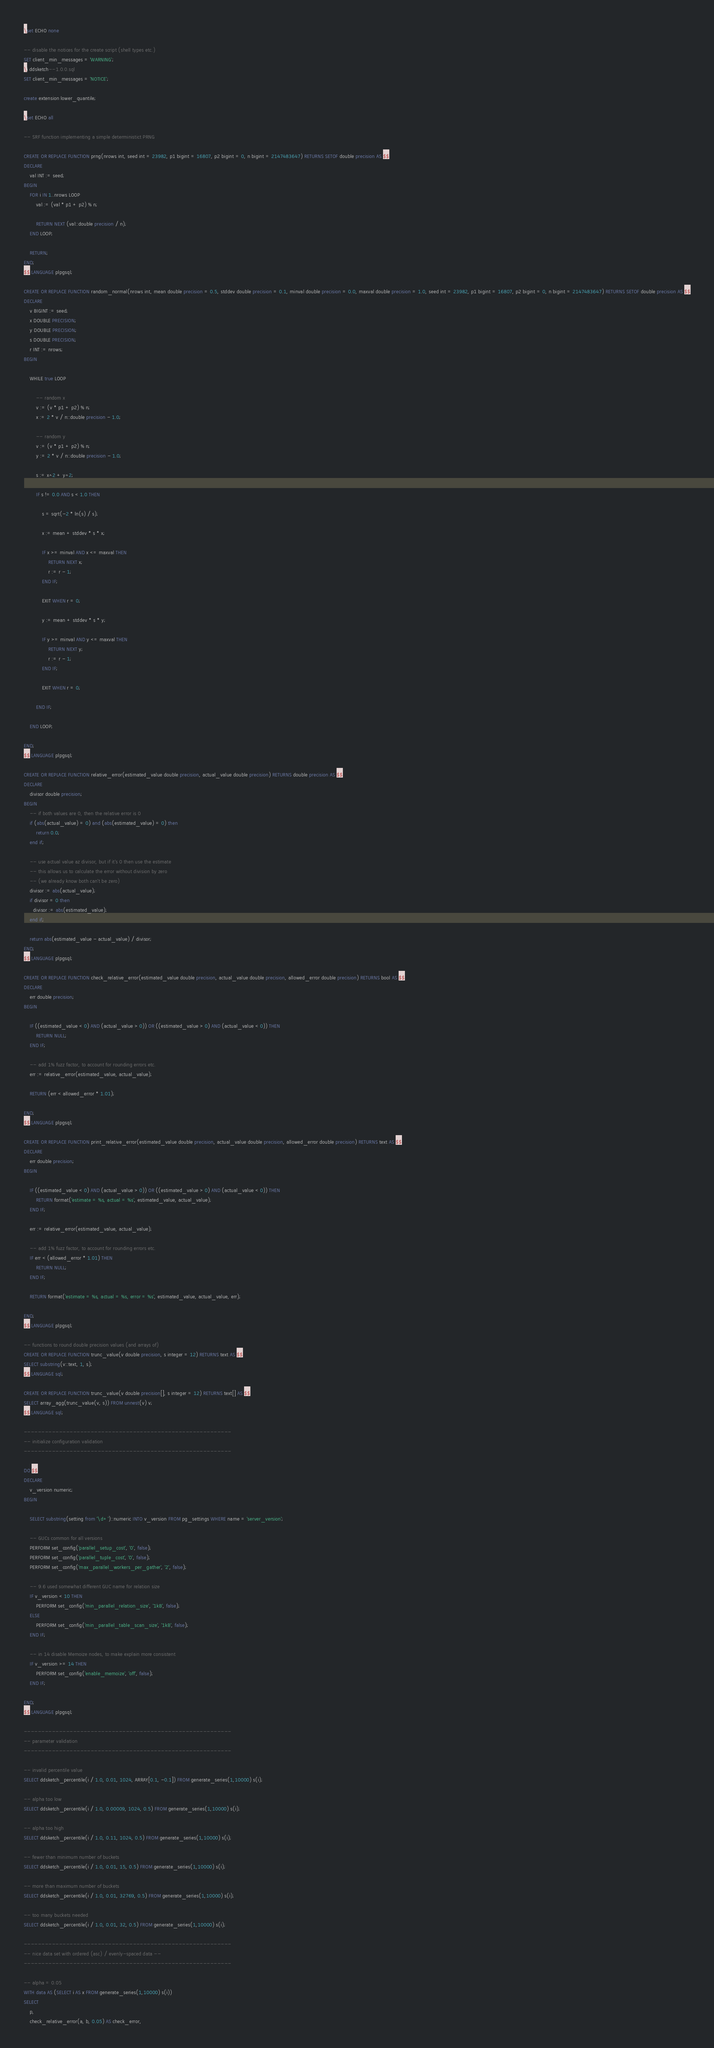<code> <loc_0><loc_0><loc_500><loc_500><_SQL_>\set ECHO none

-- disable the notices for the create script (shell types etc.)
SET client_min_messages = 'WARNING';
\i ddsketch--1.0.0.sql
SET client_min_messages = 'NOTICE';

create extension lower_quantile;

\set ECHO all

-- SRF function implementing a simple deterministict PRNG

CREATE OR REPLACE FUNCTION prng(nrows int, seed int = 23982, p1 bigint = 16807, p2 bigint = 0, n bigint = 2147483647) RETURNS SETOF double precision AS $$
DECLARE
    val INT := seed;
BEGIN
    FOR i IN 1..nrows LOOP
        val := (val * p1 + p2) % n;

        RETURN NEXT (val::double precision / n);
    END LOOP;

    RETURN;
END;
$$ LANGUAGE plpgsql;

CREATE OR REPLACE FUNCTION random_normal(nrows int, mean double precision = 0.5, stddev double precision = 0.1, minval double precision = 0.0, maxval double precision = 1.0, seed int = 23982, p1 bigint = 16807, p2 bigint = 0, n bigint = 2147483647) RETURNS SETOF double precision AS $$
DECLARE
    v BIGINT := seed;
    x DOUBLE PRECISION;
    y DOUBLE PRECISION;
    s DOUBLE PRECISION;
    r INT := nrows;
BEGIN

    WHILE true LOOP

        -- random x
        v := (v * p1 + p2) % n;
        x := 2 * v / n::double precision - 1.0;

        -- random y
        v := (v * p1 + p2) % n;
        y := 2 * v / n::double precision - 1.0;

        s := x^2 + y^2;

        IF s != 0.0 AND s < 1.0 THEN

            s = sqrt(-2 * ln(s) / s);

            x := mean + stddev * s * x;

            IF x >= minval AND x <= maxval THEN
                RETURN NEXT x;
                r := r - 1;
            END IF;

            EXIT WHEN r = 0;

            y := mean + stddev * s * y;

            IF y >= minval AND y <= maxval THEN
                RETURN NEXT y;
                r := r - 1;
            END IF;

            EXIT WHEN r = 0;

        END IF;

    END LOOP;

END;
$$ LANGUAGE plpgsql;

CREATE OR REPLACE FUNCTION relative_error(estimated_value double precision, actual_value double precision) RETURNS double precision AS $$
DECLARE
    divisor double precision;
BEGIN
    -- if both values are 0, then the relative error is 0
    if (abs(actual_value) = 0) and (abs(estimated_value) = 0) then
        return 0.0;
    end if;

    -- use actual value az divisor, but if it's 0 then use the estimate
    -- this allows us to calculate the error without division by zero
    -- (we already know both can't be zero)
    divisor := abs(actual_value);
    if divisor = 0 then
      divisor := abs(estimated_value);
    end if;

    return abs(estimated_value - actual_value) / divisor;
END;
$$ LANGUAGE plpgsql;

CREATE OR REPLACE FUNCTION check_relative_error(estimated_value double precision, actual_value double precision, allowed_error double precision) RETURNS bool AS $$
DECLARE
    err double precision;
BEGIN

    IF ((estimated_value < 0) AND (actual_value > 0)) OR ((estimated_value > 0) AND (actual_value < 0)) THEN
        RETURN NULL;
    END IF;

    -- add 1% fuzz factor, to account for rounding errors etc.
    err := relative_error(estimated_value, actual_value);

    RETURN (err < allowed_error * 1.01);

END;
$$ LANGUAGE plpgsql;

CREATE OR REPLACE FUNCTION print_relative_error(estimated_value double precision, actual_value double precision, allowed_error double precision) RETURNS text AS $$
DECLARE
    err double precision;
BEGIN

    IF ((estimated_value < 0) AND (actual_value > 0)) OR ((estimated_value > 0) AND (actual_value < 0)) THEN
        RETURN format('estimate = %s, actual = %s', estimated_value, actual_value);
    END IF;

    err := relative_error(estimated_value, actual_value);

    -- add 1% fuzz factor, to account for rounding errors etc.
    IF err < (allowed_error * 1.01) THEN
        RETURN NULL;
    END IF;

    RETURN format('estimate = %s, actual = %s, error = %s', estimated_value, actual_value, err);

END;
$$ LANGUAGE plpgsql;

-- functions to round double precision values (and arrays of)
CREATE OR REPLACE FUNCTION trunc_value(v double precision, s integer = 12) RETURNS text AS $$
SELECT substring(v::text, 1, s);
$$ LANGUAGE sql;

CREATE OR REPLACE FUNCTION trunc_value(v double precision[], s integer = 12) RETURNS text[] AS $$
SELECT array_agg(trunc_value(v, s)) FROM unnest(v) v;
$$ LANGUAGE sql;

-----------------------------------------------------------
-- initialize configuration validation
-----------------------------------------------------------

DO $$
DECLARE
    v_version numeric;
BEGIN

    SELECT substring(setting from '\d+')::numeric INTO v_version FROM pg_settings WHERE name = 'server_version';

    -- GUCs common for all versions
    PERFORM set_config('parallel_setup_cost', '0', false);
    PERFORM set_config('parallel_tuple_cost', '0', false);
    PERFORM set_config('max_parallel_workers_per_gather', '2', false);

    -- 9.6 used somewhat different GUC name for relation size
    IF v_version < 10 THEN
        PERFORM set_config('min_parallel_relation_size', '1kB', false);
    ELSE
        PERFORM set_config('min_parallel_table_scan_size', '1kB', false);
    END IF;

    -- in 14 disable Memoize nodes, to make explain more consistent
    IF v_version >= 14 THEN
        PERFORM set_config('enable_memoize', 'off', false);
    END IF;

END;
$$ LANGUAGE plpgsql;

-----------------------------------------------------------
-- parameter validation
-----------------------------------------------------------

-- invalid percentile value
SELECT ddsketch_percentile(i / 1.0, 0.01, 1024, ARRAY[0.1, -0.1]) FROM generate_series(1,10000) s(i);

-- alpha too low
SELECT ddsketch_percentile(i / 1.0, 0.00009, 1024, 0.5) FROM generate_series(1,10000) s(i);

-- alpha too high
SELECT ddsketch_percentile(i / 1.0, 0.11, 1024, 0.5) FROM generate_series(1,10000) s(i);

-- fewer than minimum number of buckets
SELECT ddsketch_percentile(i / 1.0, 0.01, 15, 0.5) FROM generate_series(1,10000) s(i);

-- more than maximum number of buckets
SELECT ddsketch_percentile(i / 1.0, 0.01, 32769, 0.5) FROM generate_series(1,10000) s(i);

-- too many buckets needed
SELECT ddsketch_percentile(i / 1.0, 0.01, 32, 0.5) FROM generate_series(1,10000) s(i);

-----------------------------------------------------------
-- nice data set with ordered (asc) / evenly-spaced data --
-----------------------------------------------------------

-- alpha = 0.05
WITH data AS (SELECT i AS x FROM generate_series(1,10000) s(i))
SELECT
    p,
    check_relative_error(a, b, 0.05) AS check_error,</code> 